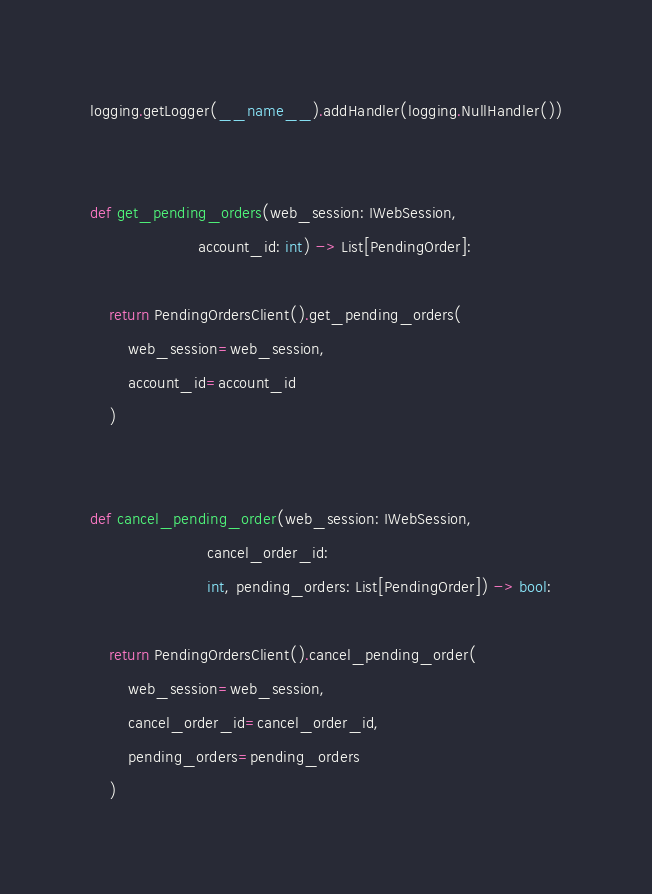<code> <loc_0><loc_0><loc_500><loc_500><_Python_>
logging.getLogger(__name__).addHandler(logging.NullHandler())


def get_pending_orders(web_session: IWebSession,
                       account_id: int) -> List[PendingOrder]:

    return PendingOrdersClient().get_pending_orders(
        web_session=web_session,
        account_id=account_id
    )


def cancel_pending_order(web_session: IWebSession,
                         cancel_order_id:
                         int, pending_orders: List[PendingOrder]) -> bool:

    return PendingOrdersClient().cancel_pending_order(
        web_session=web_session,
        cancel_order_id=cancel_order_id,
        pending_orders=pending_orders
    )
</code> 